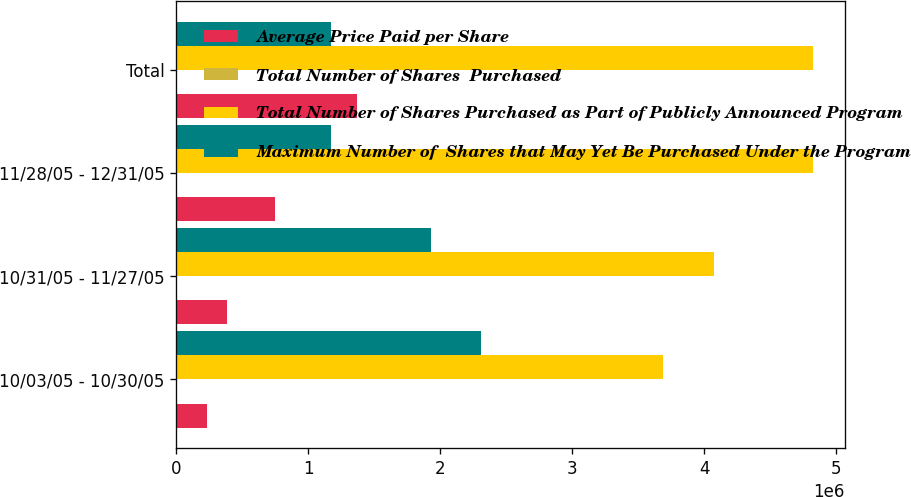Convert chart. <chart><loc_0><loc_0><loc_500><loc_500><stacked_bar_chart><ecel><fcel>10/03/05 - 10/30/05<fcel>10/31/05 - 11/27/05<fcel>11/28/05 - 12/31/05<fcel>Total<nl><fcel>Average Price Paid per Share<fcel>237500<fcel>382500<fcel>750500<fcel>1.3705e+06<nl><fcel>Total Number of Shares  Purchased<fcel>115.5<fcel>115.9<fcel>114.41<fcel>115.01<nl><fcel>Total Number of Shares Purchased as Part of Publicly Announced Program<fcel>3.6901e+06<fcel>4.0726e+06<fcel>4.8231e+06<fcel>4.8231e+06<nl><fcel>Maximum Number of  Shares that May Yet Be Purchased Under the Program<fcel>2.3099e+06<fcel>1.9274e+06<fcel>1.1769e+06<fcel>1.1769e+06<nl></chart> 